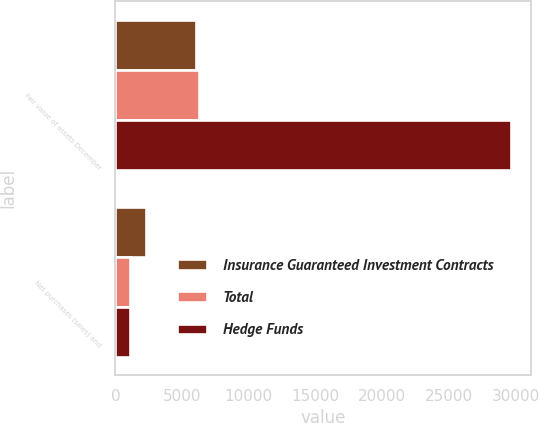<chart> <loc_0><loc_0><loc_500><loc_500><stacked_bar_chart><ecel><fcel>Fair value of assets December<fcel>Net purchases (sales) and<nl><fcel>Insurance Guaranteed Investment Contracts<fcel>6018<fcel>2262<nl><fcel>Total<fcel>6266<fcel>1136<nl><fcel>Hedge Funds<fcel>29697<fcel>1126<nl></chart> 